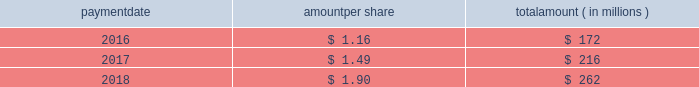Humana inc .
Notes to consolidated financial statements 2014 ( continued ) 15 .
Stockholders 2019 equity dividends the table provides details of dividend payments , excluding dividend equivalent rights , in 2016 , 2017 , and 2018 under our board approved quarterly cash dividend policy : payment amount per share amount ( in millions ) .
On november 2 , 2018 , the board declared a cash dividend of $ 0.50 per share that was paid on january 25 , 2019 to stockholders of record on december 31 , 2018 , for an aggregate amount of $ 68 million .
Declaration and payment of future quarterly dividends is at the discretion of our board and may be adjusted as business needs or market conditions change .
In february 2019 , the board declared a cash dividend of $ 0.55 per share payable on april 26 , 2019 to stockholders of record on march 29 , 2019 .
Stock repurchases our board of directors may authorize the purchase of our common shares .
Under our share repurchase authorization , shares may have been purchased from time to time at prevailing prices in the open market , by block purchases , through plans designed to comply with rule 10b5-1 under the securities exchange act of 1934 , as amended , or in privately-negotiated transactions ( including pursuant to accelerated share repurchase agreements with investment banks ) , subject to certain regulatory restrictions on volume , pricing , and timing .
On february 14 , 2017 , our board of directors authorized the repurchase of up to $ 2.25 billion of our common shares expiring on december 31 , 2017 , exclusive of shares repurchased in connection with employee stock plans .
On february 16 , 2017 , we entered into an accelerated share repurchase agreement , the february 2017 asr , with goldman , sachs & co .
Llc , or goldman sachs , to repurchase $ 1.5 billion of our common stock as part of the $ 2.25 billion share repurchase authorized on february 14 , 2017 .
On february 22 , 2017 , we made a payment of $ 1.5 billion to goldman sachs from available cash on hand and received an initial delivery of 5.83 million shares of our common stock from goldman sachs based on the then current market price of humana common stock .
The payment to goldman sachs was recorded as a reduction to stockholders 2019 equity , consisting of a $ 1.2 billion increase in treasury stock , which reflected the value of the initial 5.83 million shares received upon initial settlement , and a $ 300 million decrease in capital in excess of par value , which reflected the value of stock held back by goldman sachs pending final settlement of the february 2017 asr .
Upon settlement of the february 2017 asr on august 28 , 2017 , we received an additional 0.84 million shares as determined by the average daily volume weighted-average share price of our common stock during the term of the agreement of $ 224.81 , less a discount and subject to adjustments pursuant to the terms and conditions of the february 2017 asr , bringing the total shares received under this program to 6.67 million .
In addition , upon settlement we reclassified the $ 300 million value of stock initially held back by goldman sachs from capital in excess of par value to treasury stock .
Subsequent to settlement of the february 2017 asr , we repurchased an additional 3.04 million shares in the open market , utilizing the remaining $ 750 million of the $ 2.25 billion authorization prior to expiration .
On december 14 , 2017 , our board of directors authorized the repurchase of up to $ 3.0 billion of our common shares expiring on december 31 , 2020 , exclusive of shares repurchased in connection with employee stock plans. .
Considering the year 2018 , what is the percentage of the cash dividend paid per share concerning the total amount paid per share? 
Rationale: it is the amount of dividend paid per share divided by the total amount paid per share , then turned into a percentage .
Computations: (0.50 / 1.90)
Answer: 0.26316. 